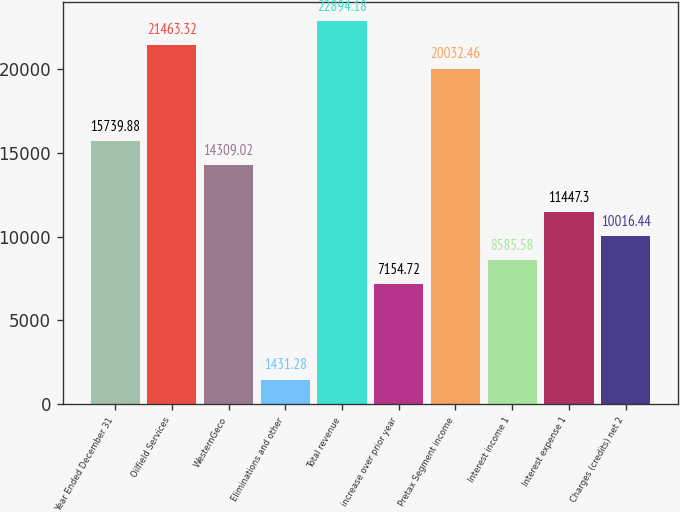Convert chart to OTSL. <chart><loc_0><loc_0><loc_500><loc_500><bar_chart><fcel>Year Ended December 31<fcel>Oilfield Services<fcel>WesternGeco<fcel>Eliminations and other<fcel>Total revenue<fcel>increase over prior year<fcel>Pretax Segment income<fcel>Interest income 1<fcel>Interest expense 1<fcel>Charges (credits) net 2<nl><fcel>15739.9<fcel>21463.3<fcel>14309<fcel>1431.28<fcel>22894.2<fcel>7154.72<fcel>20032.5<fcel>8585.58<fcel>11447.3<fcel>10016.4<nl></chart> 